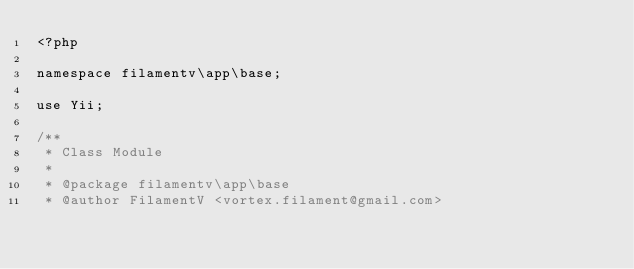Convert code to text. <code><loc_0><loc_0><loc_500><loc_500><_PHP_><?php

namespace filamentv\app\base;

use Yii;

/**
 * Class Module
 *
 * @package filamentv\app\base
 * @author FilamentV <vortex.filament@gmail.com></code> 